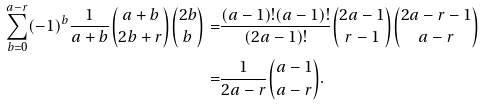<formula> <loc_0><loc_0><loc_500><loc_500>\sum _ { b = 0 } ^ { a - r } ( - 1 ) ^ { b } \frac { 1 } { a + b } \binom { a + b } { 2 b + r } \binom { 2 b } { b } = & \frac { ( a - 1 ) ! ( a - 1 ) ! } { ( 2 a - 1 ) ! } \binom { 2 a - 1 } { r - 1 } \binom { 2 a - r - 1 } { a - r } \\ = & \frac { 1 } { 2 a - r } \binom { a - 1 } { a - r } . \\</formula> 